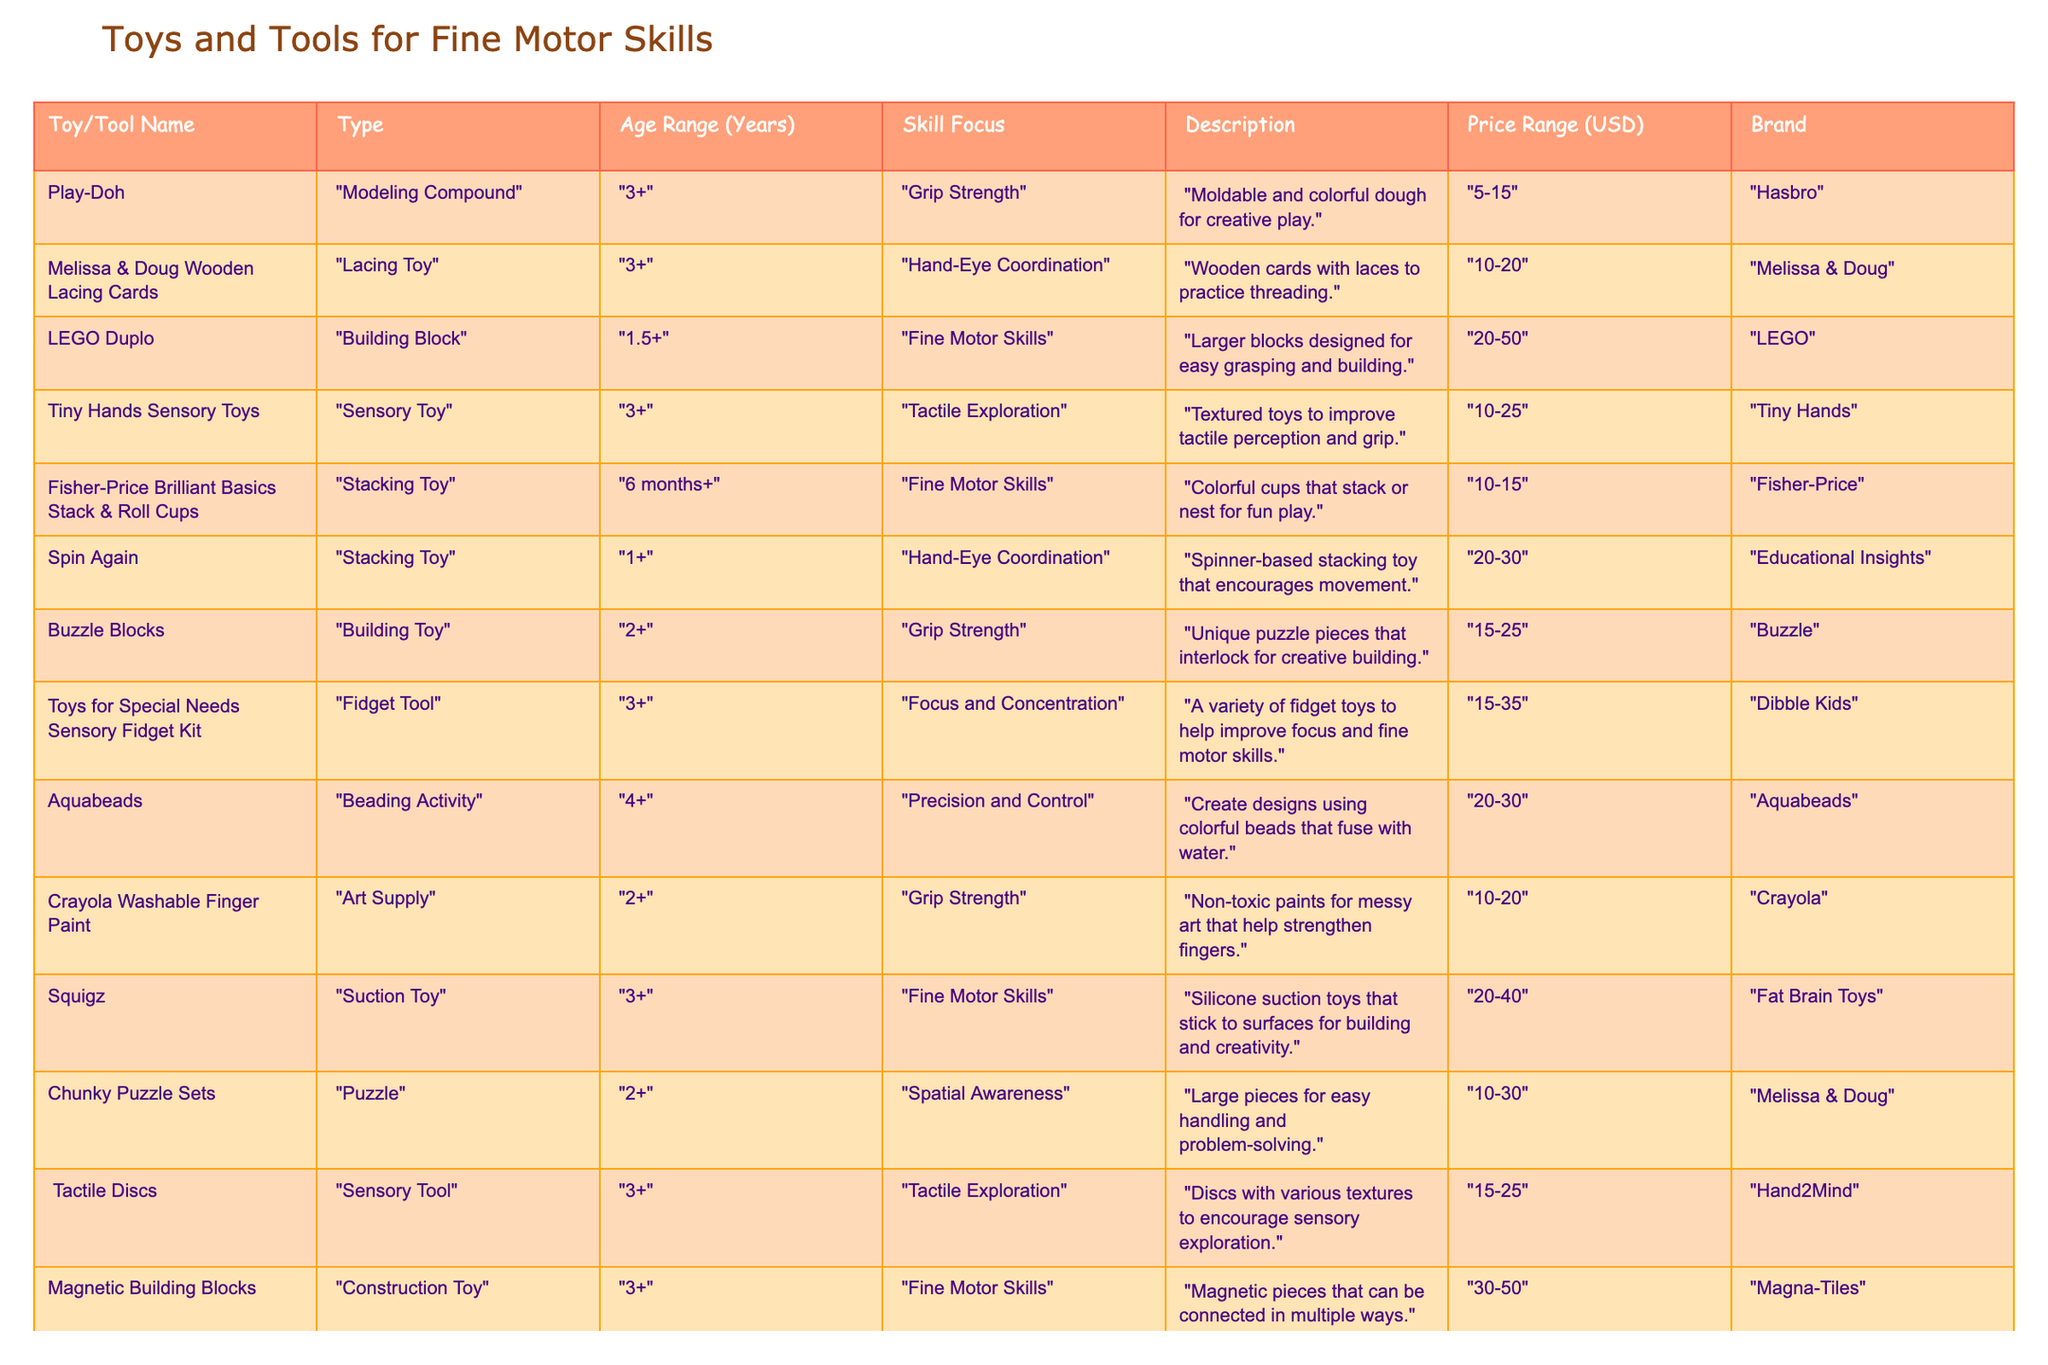What is the price range for "LEGO Duplo"? The table lists the "Price Range (USD)" for "LEGO Duplo" as "20-50".
Answer: 20-50 Which toy focuses on "Grip Strength" and is suitable for ages "2+"? According to the table, "Crayola Washable Finger Paint" and "Buzzle Blocks" both focus on "Grip Strength" and are suitable for ages "2+".
Answer: Crayola Washable Finger Paint and Buzzle Blocks How many toys are designed for "Hand-Eye Coordination"? The table indicates that "Melissa & Doug Wooden Lacing Cards" and "Spin Again" focus on "Hand-Eye Coordination", which makes a total of two toys.
Answer: 2 Is "Aquabeads" suitable for an age younger than 4 years? The table states that "Aquabeads" has an age range of "4+", which means it is not suitable for younger ages.
Answer: No Which tool has the highest price range? In examining the table, "Magnetic Building Blocks" has the highest price range of "30-50".
Answer: 30-50 What toys can help improve "Focus and Concentration"? The table lists "Toys for Special Needs Sensory Fidget Kit" and "Fidget Spinner" as toys that help improve "Focus and Concentration".
Answer: Toys for Special Needs Sensory Fidget Kit and Fidget Spinner What is the age range for "Fisher-Price Brilliant Basics Stack & Roll Cups"? The "Fisher-Price Brilliant Basics Stack & Roll Cups" are suitable for ages "6 months+".
Answer: 6 months+ Count the number of toys that focus on "Tactile Exploration". Referring to the table, there are two toys focused on "Tactile Exploration": "Tiny Hands Sensory Toys" and "Tactile Discs".
Answer: 2 How much more expensive is the most expensive toy compared to the least expensive toy? The most expensive toy is "Magnetic Building Blocks" with a range of "30-50", and the least expensive toy is "Fidget Spinner" with a range of "5-15". Taking the maximum of each, 50 - 5 = 45.
Answer: 45 Which brand has the most toys listed in the table? By examining the table, "Melissa & Doug" appears to have three toys listed: "Melissa & Doug Wooden Lacing Cards", "Chunky Puzzle Sets", and "Tactile Discs". Therefore, it has the most toys.
Answer: Melissa & Doug 